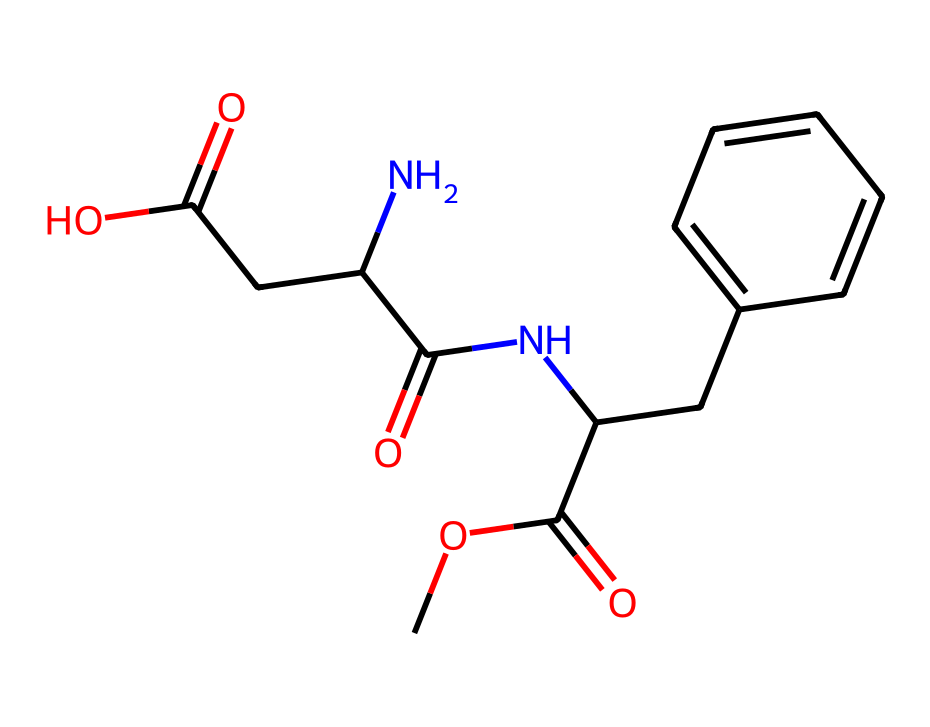What is the molecular formula of this chemical? By analyzing the provided SMILES representation, we can identify the atoms present. The components consist of carbon (C), hydrogen (H), nitrogen (N), and oxygen (O). Counting the atoms gives us C14, H18, N2, O5.
Answer: C14H18N2O5 How many rings are present in this structure? Looking at the chemical structure from the SMILES, there is a six-member carbon ring (the benzene part is indicated by 'C1=CC=CC=C1'). There are no additional rings.
Answer: 1 What type of functional groups can be identified? Examining the structure reveals the presence of an amine (NH) group, carboxylic acid (COOH), and ester (COO) groups. These functional groups contribute to the properties of the chemical.
Answer: amine, carboxylic acid, ester Is this compound a sweetener? Aspartame is known to be a low-calorie artificial sweetener, and the presence of specific functional groups and its molecular structure support this classification.
Answer: yes How many hydrogen atoms are bonded to carbon atoms in this compound? Counting the hydrogens bonded to carbons from the structure, it can be seen that there are 18 hydrogen atoms associated with the 14 carbon atoms, based on typical bonding patterns in organic compounds.
Answer: 18 Which atoms in the structure are responsible for its sweetness? The nitrogen atoms in the structure (N2) are part of the amine functionality significant in sweeteners; thus, they contribute to the perceived sweetness profile along with the overall structure.
Answer: nitrogen 